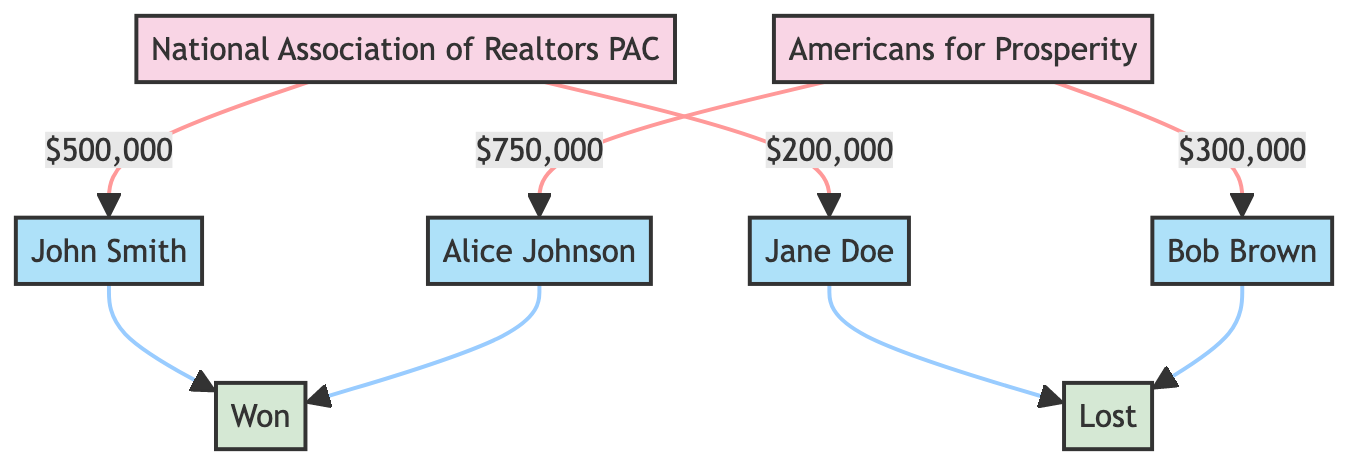What is the total amount contributed by the National Association of Realtors PAC? By examining the edges connected to the National Association of Realtors PAC, we see two contributions: one of $500,000 to John Smith and another of $200,000 to Jane Doe. Summing these amounts gives $500,000 + $200,000 = $700,000.
Answer: $700,000 How many candidates received contributions from the Americans for Prosperity PAC? The Americans for Prosperity PAC is connected to two candidates, Alice Johnson and Bob Brown, via directed edges representing contributions. Thus, the total is two candidates.
Answer: 2 What was the outcome for Jane Doe? Looking at the directed edge from the contributions to Jane Doe, it is connected to the outcome labeled "Lost." Therefore, her election result was a loss.
Answer: Lost Which candidate received the highest contribution? By comparing the contribution amounts linked to each candidate, we see John Smith received $500,000, Alice Johnson received $750,000, Jane Doe received $200,000, and Bob Brown received $300,000. The highest amount is $750,000 for Alice Johnson.
Answer: Alice Johnson What is the relationship between contributions from PACs and election outcomes? The diagram illustrates that contributions from PACs (represented by edges connecting PAC nodes to candidate nodes) lead to the election outcomes (connected nodes). If a candidate received a higher contribution, they are more likely to have a directed edge to the outcome "Won." This indicates a link between greater financial backing and success in elections.
Answer: Positive correlation How many total edges are drawn from PACs to candidates in the diagram? There are four directed edges in total: two from the National Association of Realtors PAC to its candidates and two from Americans for Prosperity to its candidates. Thus, the total number of edges from PACs to candidates is four.
Answer: 4 Which PAC contributed to John Smith? The diagram shows a directed edge from the National Association of Realtors PAC to John Smith, indicating that this PAC made a contribution to him.
Answer: National Association of Realtors PAC Identify the election outcome associated with Bob Brown. Bob Brown is connected to the outcome labeled "Lost" in the diagram, which shows the election result for him based on the contributions he received from the PAC.
Answer: Lost 